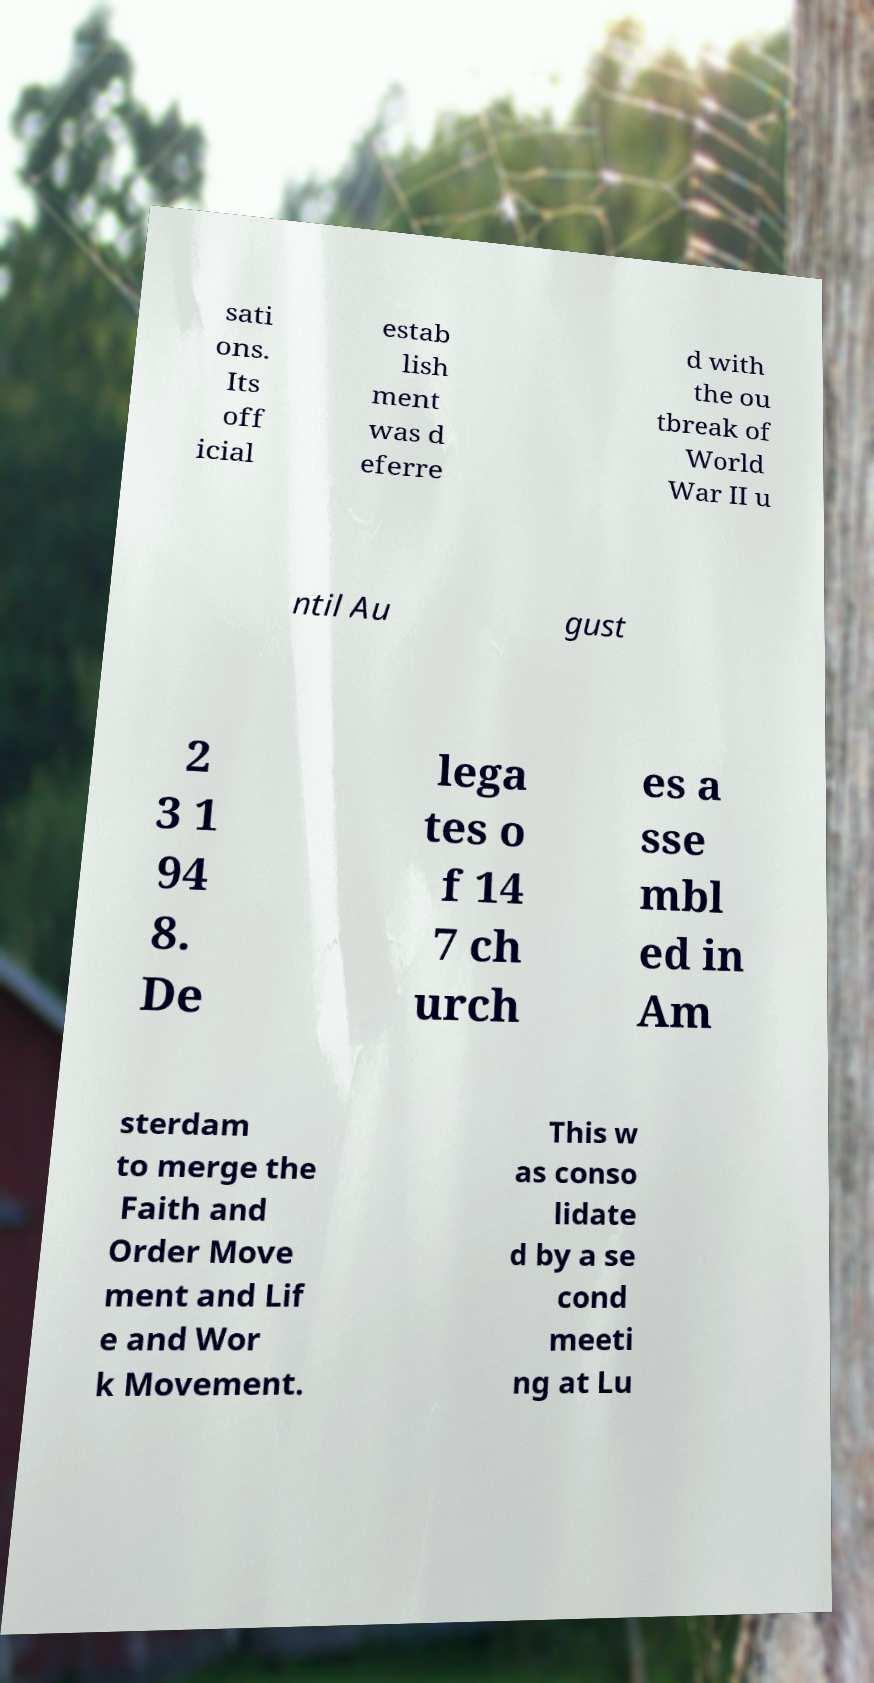Can you read and provide the text displayed in the image?This photo seems to have some interesting text. Can you extract and type it out for me? sati ons. Its off icial estab lish ment was d eferre d with the ou tbreak of World War II u ntil Au gust 2 3 1 94 8. De lega tes o f 14 7 ch urch es a sse mbl ed in Am sterdam to merge the Faith and Order Move ment and Lif e and Wor k Movement. This w as conso lidate d by a se cond meeti ng at Lu 